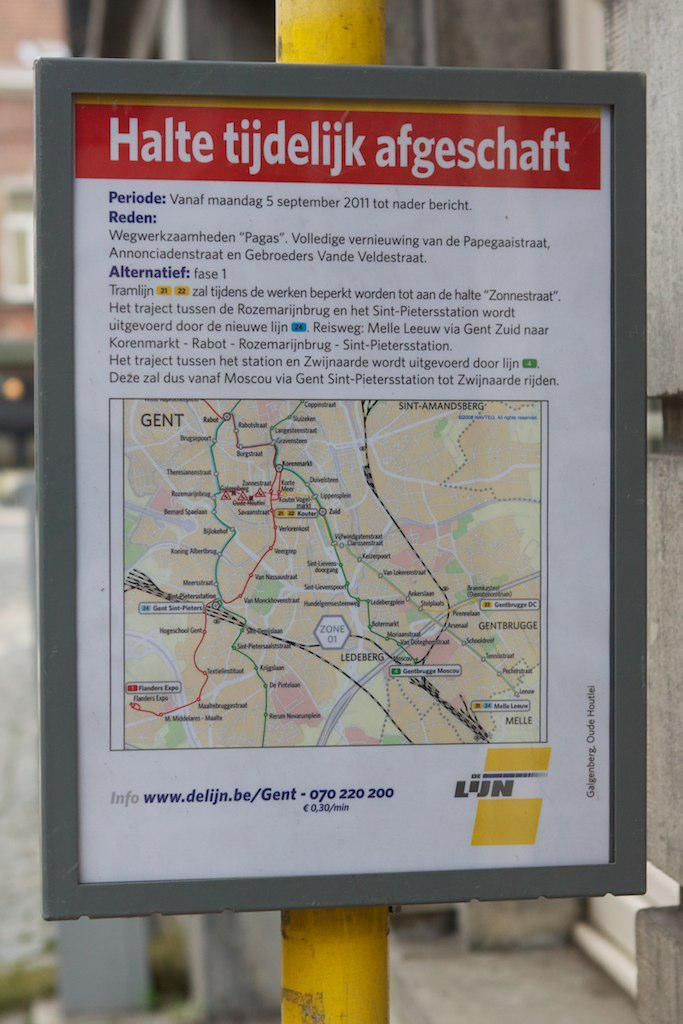What is the main object in the center of the image? There is a board in the center of the image. How is the board positioned in the image? The board is placed on a pole. What can be seen in the background of the image? There are buildings in the background of the image. What type of wheel is attached to the board in the image? There is no wheel attached to the board in the image. Can you see any volleyball players in the image? There is no indication of volleyball or players in the image. 